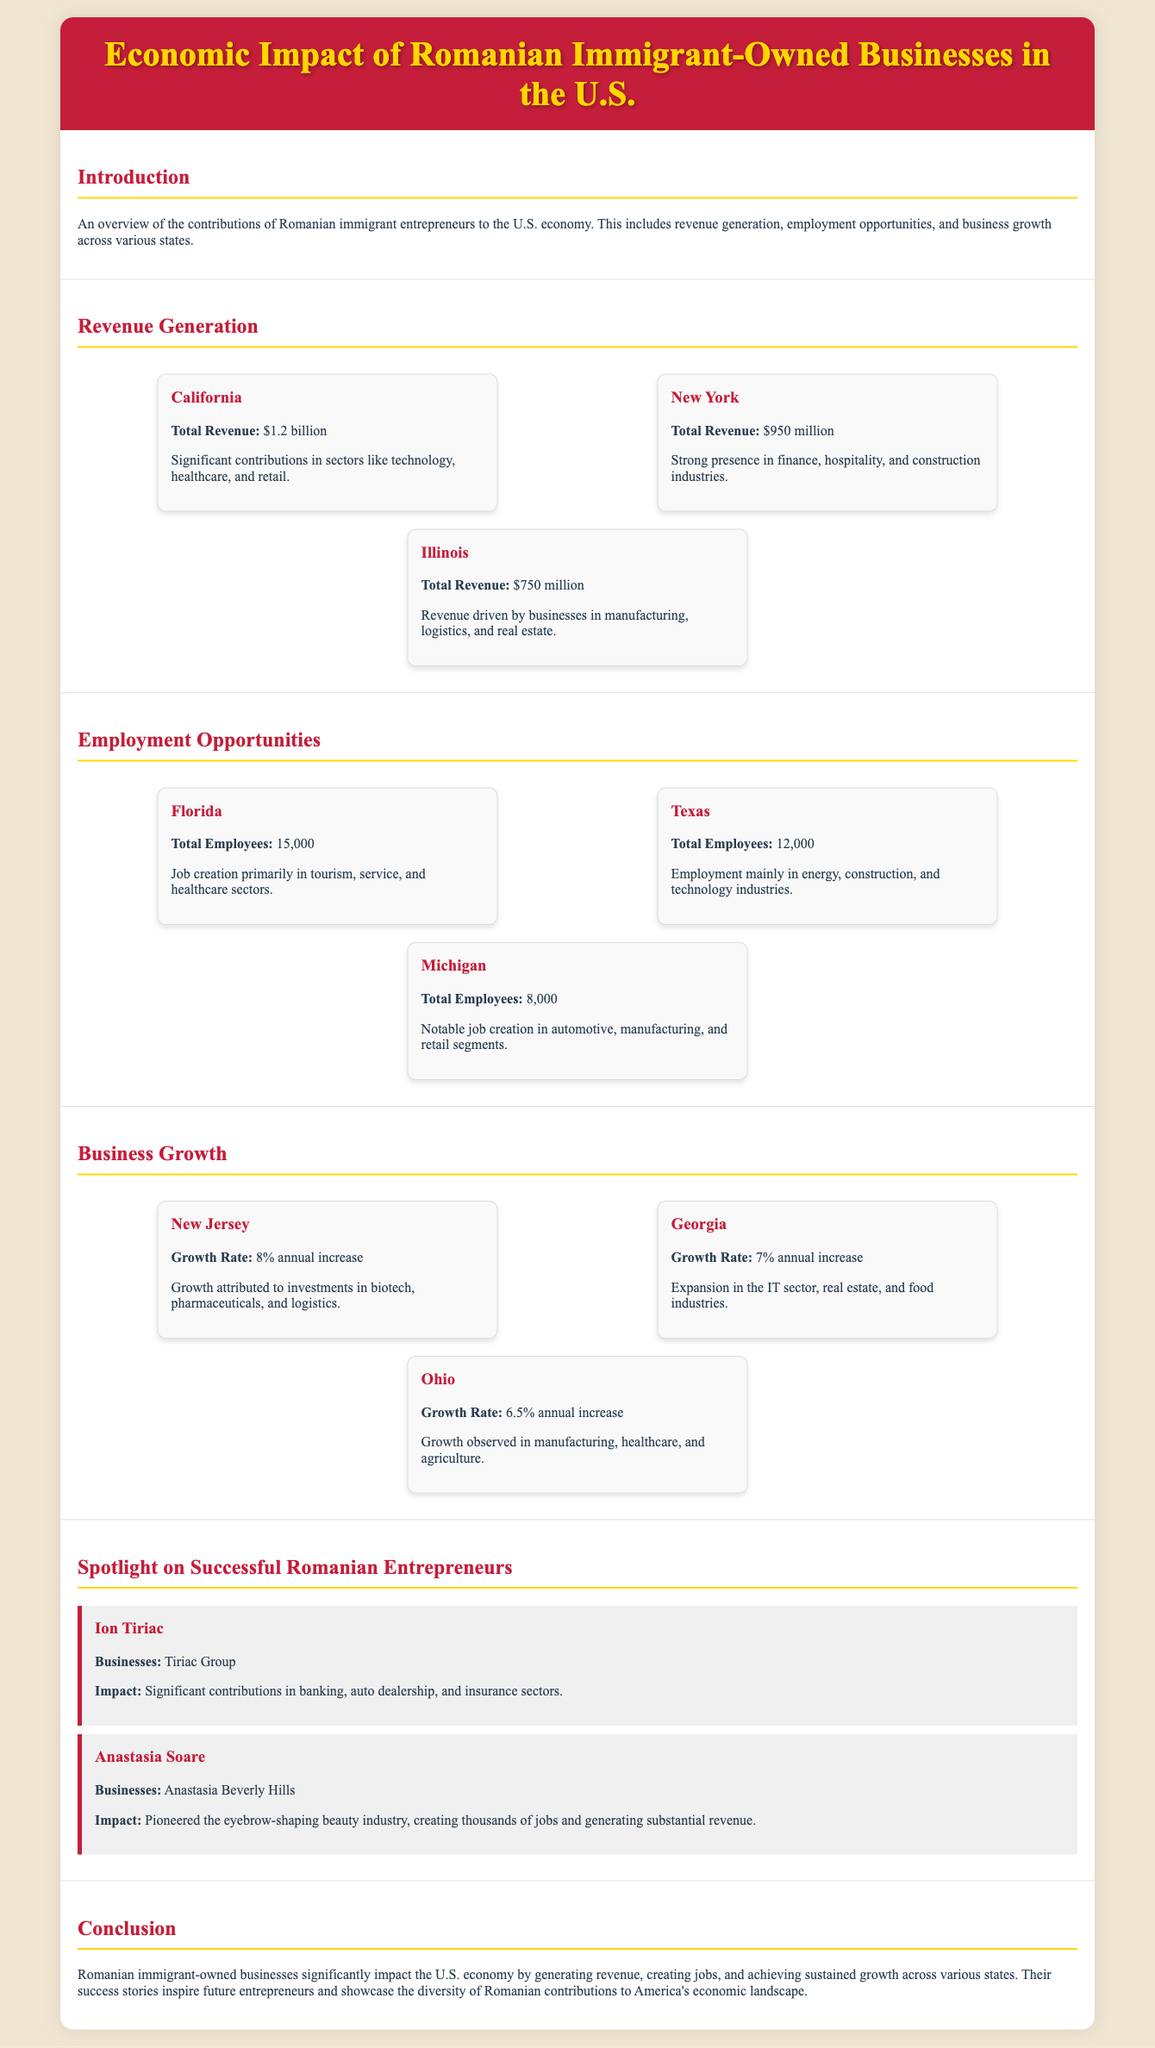what is the total revenue for California? The total revenue for California is listed in the revenue section of the document as $1.2 billion.
Answer: $1.2 billion how many total employees are in Florida? The total employees for Florida are detailed in the employment section as 15,000.
Answer: 15,000 what is the growth rate for New Jersey? The growth rate for New Jersey is provided in the business growth section as 8% annual increase.
Answer: 8% annual increase which sector contributed to significant revenue in Illinois? The document specifies that revenue in Illinois is driven by businesses in the manufacturing, logistics, and real estate sectors.
Answer: manufacturing, logistics, and real estate who is the entrepreneur associated with Anastasia Beverly Hills? The document mentions Anastasia Soare as the entrepreneur associated with Anastasia Beverly Hills.
Answer: Anastasia Soare which state has the highest employment opportunities among the listed states? By comparing the total employees from Florida, Texas, and Michigan, Florida has the highest employment opportunities with 15,000 employees.
Answer: Florida what are the main industries for businesses owned by Romanian immigrants in New York? The document indicates that the main industries in New York include finance, hospitality, and construction.
Answer: finance, hospitality, and construction which two sectors are highlighted in the growth of Georgia's businesses? The document highlights the IT sector and food industries as the sectors contributing to Georgia's business growth.
Answer: IT sector and food industries 